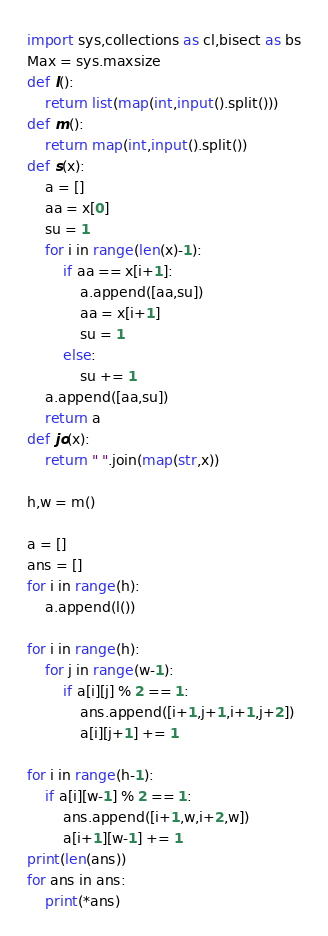Convert code to text. <code><loc_0><loc_0><loc_500><loc_500><_Python_>import sys,collections as cl,bisect as bs
Max = sys.maxsize
def l():
	return list(map(int,input().split()))
def m():
	return map(int,input().split())
def s(x):
	a = []
	aa = x[0]
	su = 1
	for i in range(len(x)-1):
		if aa == x[i+1]:
			a.append([aa,su])
			aa = x[i+1]
			su = 1
		else:
			su += 1
	a.append([aa,su])
	return a
def jo(x):
	return " ".join(map(str,x))

h,w = m()

a = []
ans = []
for i in range(h):
	a.append(l())

for i in range(h):
	for j in range(w-1):
		if a[i][j] % 2 == 1:
			ans.append([i+1,j+1,i+1,j+2])
			a[i][j+1] += 1

for i in range(h-1):
	if a[i][w-1] % 2 == 1:
		ans.append([i+1,w,i+2,w])
		a[i+1][w-1] += 1
print(len(ans))
for ans in ans:
	print(*ans)
</code> 